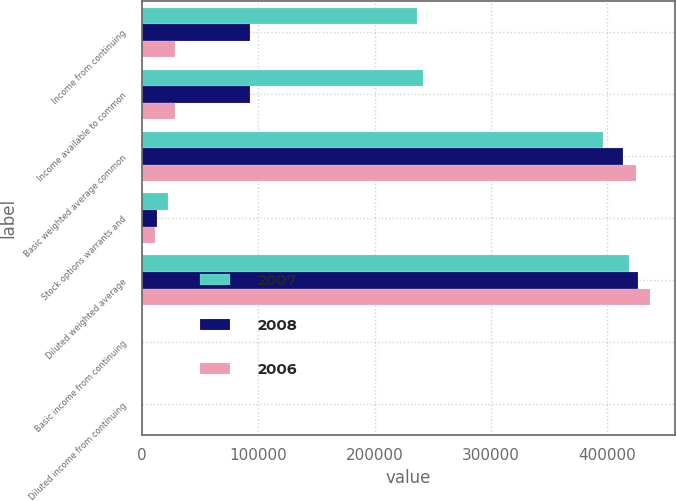<chart> <loc_0><loc_0><loc_500><loc_500><stacked_bar_chart><ecel><fcel>Income from continuing<fcel>Income available to common<fcel>Basic weighted average common<fcel>Stock options warrants and<fcel>Diluted weighted average<fcel>Basic income from continuing<fcel>Diluted income from continuing<nl><fcel>2007<fcel>236264<fcel>241488<fcel>395947<fcel>22410<fcel>418357<fcel>0.6<fcel>0.58<nl><fcel>2008<fcel>92712<fcel>92712<fcel>413167<fcel>12912<fcel>426079<fcel>0.22<fcel>0.22<nl><fcel>2006<fcel>28338<fcel>28338<fcel>424525<fcel>11692<fcel>436217<fcel>0.06<fcel>0.06<nl></chart> 